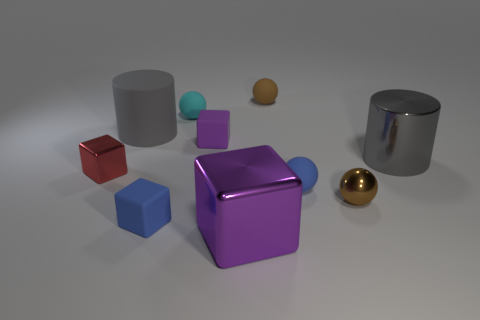Subtract all red cubes. How many brown balls are left? 2 Subtract all tiny cyan matte balls. How many balls are left? 3 Subtract all red blocks. How many blocks are left? 3 Subtract 1 cubes. How many cubes are left? 3 Subtract all blocks. How many objects are left? 6 Subtract all gray spheres. Subtract all brown blocks. How many spheres are left? 4 Subtract 0 green cubes. How many objects are left? 10 Subtract all large purple metallic blocks. Subtract all big gray rubber objects. How many objects are left? 8 Add 4 brown matte objects. How many brown matte objects are left? 5 Add 2 purple metallic objects. How many purple metallic objects exist? 3 